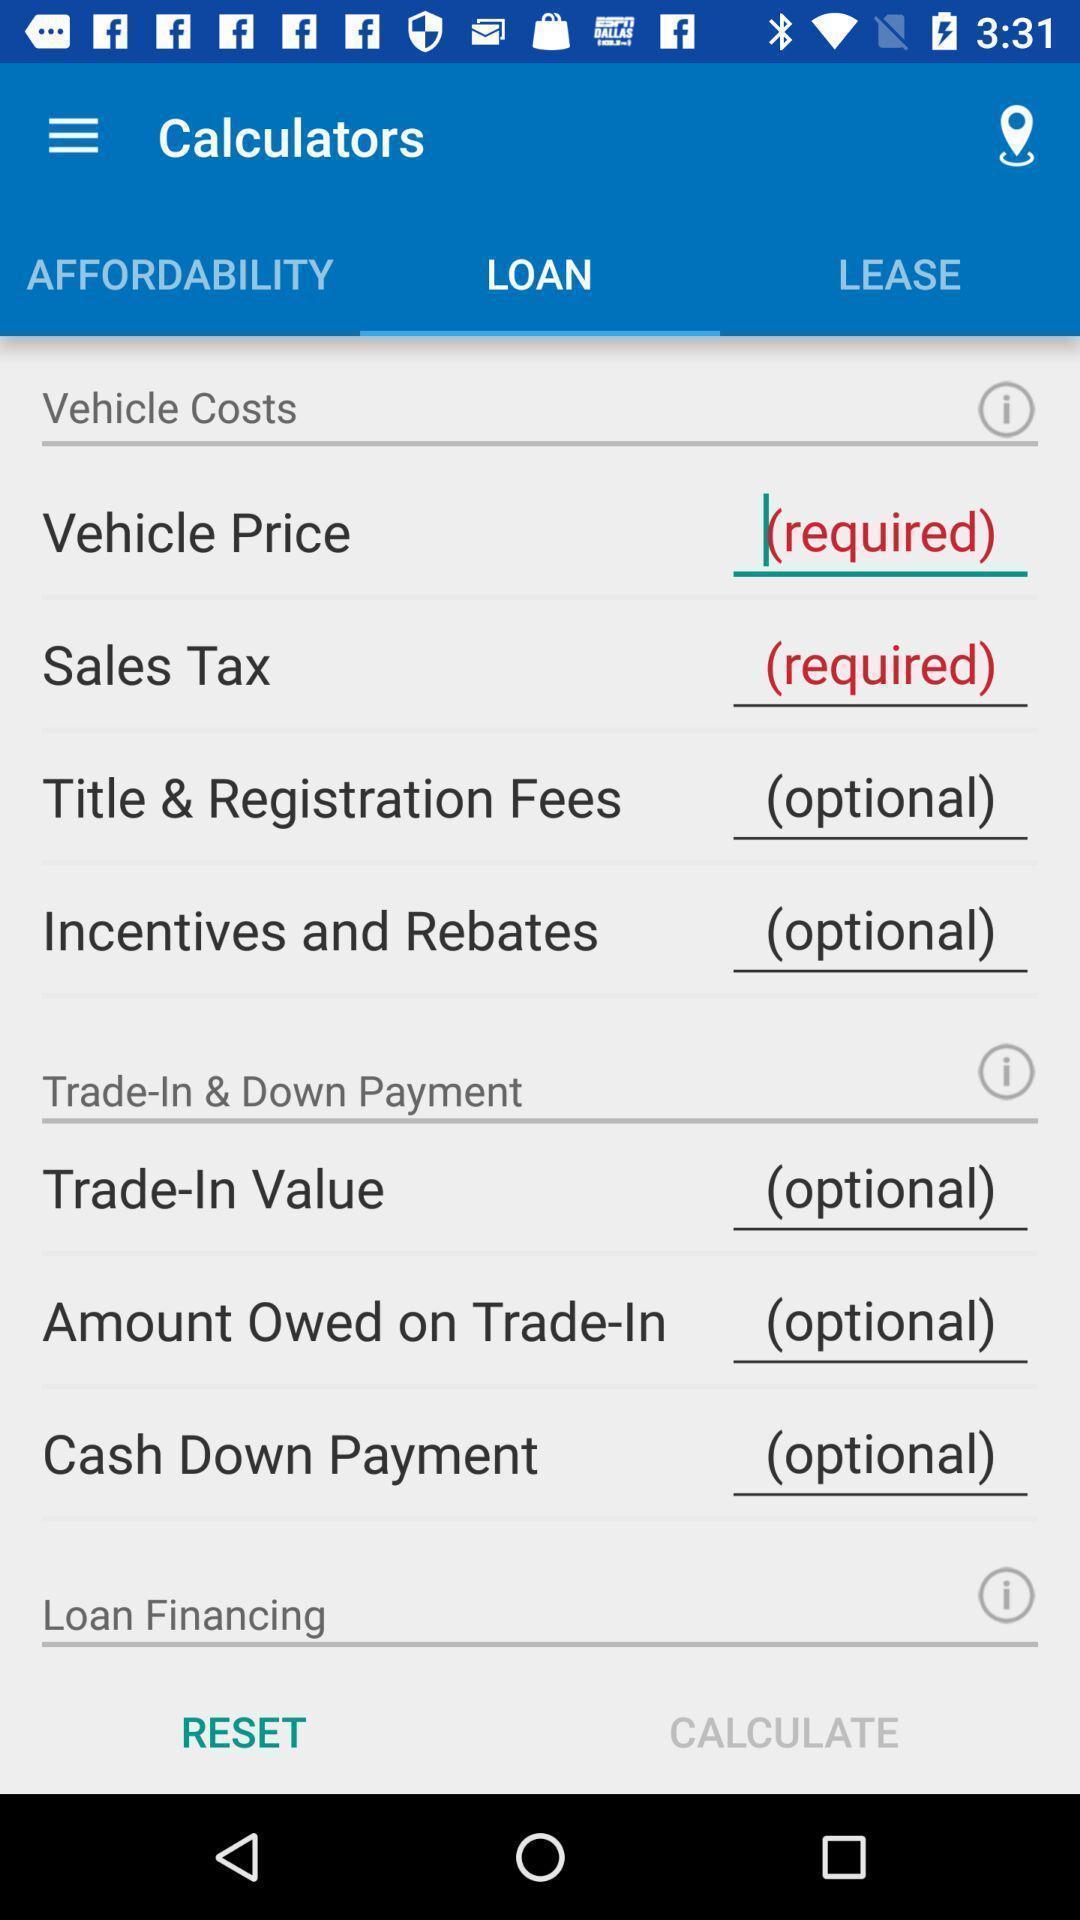Tell me what you see in this picture. Page showing input fields required for loan. 